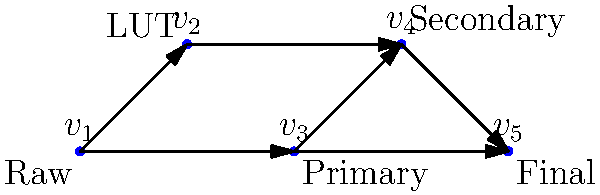In a color grading workflow represented by the directed acyclic graph above, where each vertex represents a stage in the process and edges represent the flow of work, what is the minimum number of stages that must be completed to reach the final output from the raw input? To solve this problem, we need to find the longest path from the raw input (v₁) to the final output (v₅). This is known as the critical path in project management terms.

Step 1: Identify all possible paths from v₁ to v₅:
- Path 1: v₁ → v₂ → v₄ → v₅
- Path 2: v₁ → v₃ → v₄ → v₅
- Path 3: v₁ → v₃ → v₅

Step 2: Count the number of stages (vertices) in each path:
- Path 1: 4 stages
- Path 2: 4 stages
- Path 3: 3 stages

Step 3: Identify the longest path(s):
The longest paths are Path 1 and Path 2, both with 4 stages.

Step 4: Subtract 1 from the number of stages in the longest path:
Since we're counting the minimum number of stages that must be completed, and the initial stage (raw input) doesn't count as a completed stage, we subtract 1 from 4.

4 - 1 = 3

Therefore, the minimum number of stages that must be completed to reach the final output from the raw input is 3.
Answer: 3 